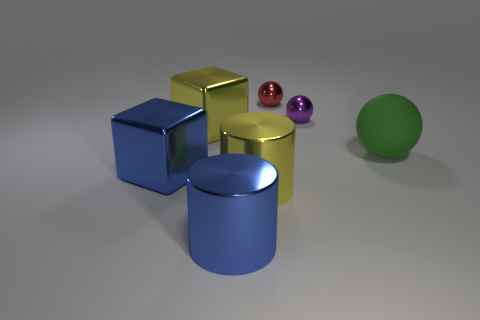Add 1 large green metal cylinders. How many objects exist? 8 Subtract all balls. How many objects are left? 4 Subtract all blue cubes. Subtract all red metallic balls. How many objects are left? 5 Add 4 large metallic things. How many large metallic things are left? 8 Add 7 big red balls. How many big red balls exist? 7 Subtract 0 gray spheres. How many objects are left? 7 